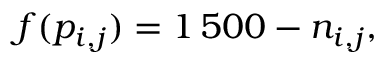Convert formula to latex. <formula><loc_0><loc_0><loc_500><loc_500>f ( p _ { i , j } ) = 1 \, 5 0 0 - n _ { i , j } ,</formula> 